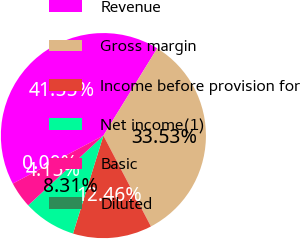<chart> <loc_0><loc_0><loc_500><loc_500><pie_chart><fcel>Revenue<fcel>Gross margin<fcel>Income before provision for<fcel>Net income(1)<fcel>Basic<fcel>Diluted<nl><fcel>41.55%<fcel>33.53%<fcel>12.46%<fcel>8.31%<fcel>4.15%<fcel>0.0%<nl></chart> 